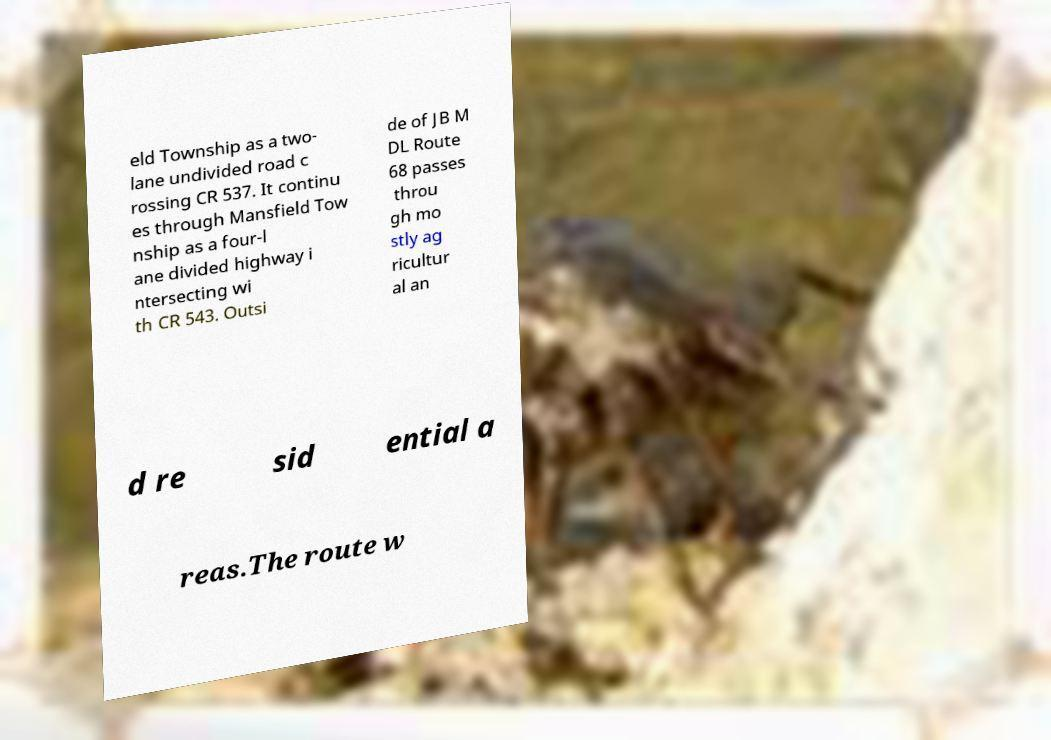Please read and relay the text visible in this image. What does it say? eld Township as a two- lane undivided road c rossing CR 537. It continu es through Mansfield Tow nship as a four-l ane divided highway i ntersecting wi th CR 543. Outsi de of JB M DL Route 68 passes throu gh mo stly ag ricultur al an d re sid ential a reas.The route w 